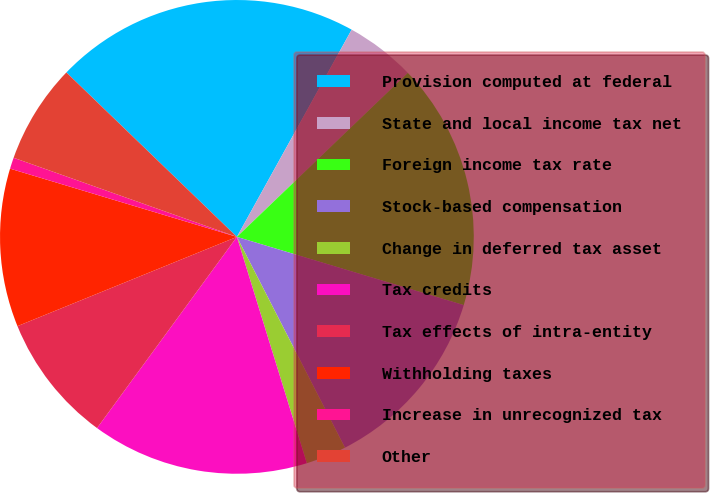<chart> <loc_0><loc_0><loc_500><loc_500><pie_chart><fcel>Provision computed at federal<fcel>State and local income tax net<fcel>Foreign income tax rate<fcel>Stock-based compensation<fcel>Change in deferred tax asset<fcel>Tax credits<fcel>Tax effects of intra-entity<fcel>Withholding taxes<fcel>Increase in unrecognized tax<fcel>Other<nl><fcel>20.84%<fcel>4.78%<fcel>16.82%<fcel>12.81%<fcel>2.77%<fcel>14.82%<fcel>8.8%<fcel>10.8%<fcel>0.77%<fcel>6.79%<nl></chart> 